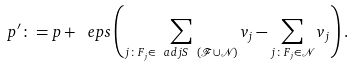Convert formula to latex. <formula><loc_0><loc_0><loc_500><loc_500>p ^ { \prime } \colon = p + \ e p s \left ( \sum _ { j \colon F _ { j } \in \ a d j S \ ( { \mathcal { F } } \cup { \mathcal { N } } ) } v _ { j } - \sum _ { j \colon F _ { j } \in { \mathcal { N } } } v _ { j } \right ) .</formula> 